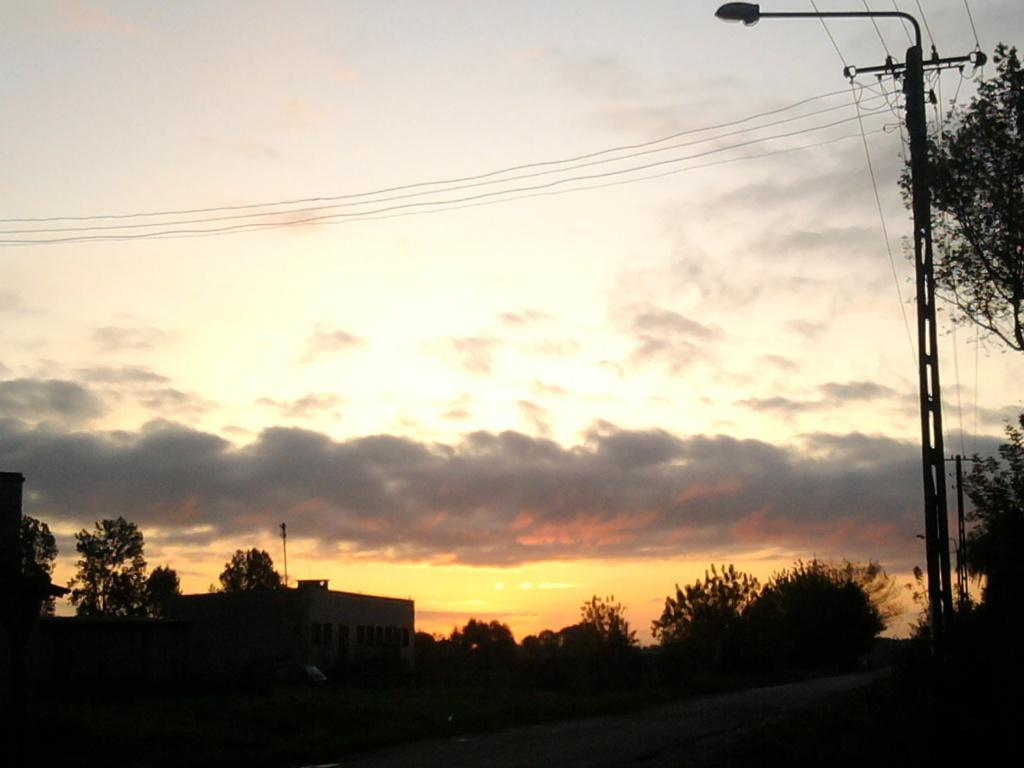What type of surface can be seen in the image? There is a road in the image. What type of vegetation is present in the image? There is grass in the image. What structures can be seen in the image? There are poles, houses, and trees in the image. What is visible in the background of the image? The sky is visible in the background of the image. What can be seen in the sky? There are clouds in the sky. What type of base is used for the learning process in the image? There is no reference to a base or learning process in the image. What is the current status of the trees in the image? The image does not provide information about the current status of the trees; it only shows their presence. 